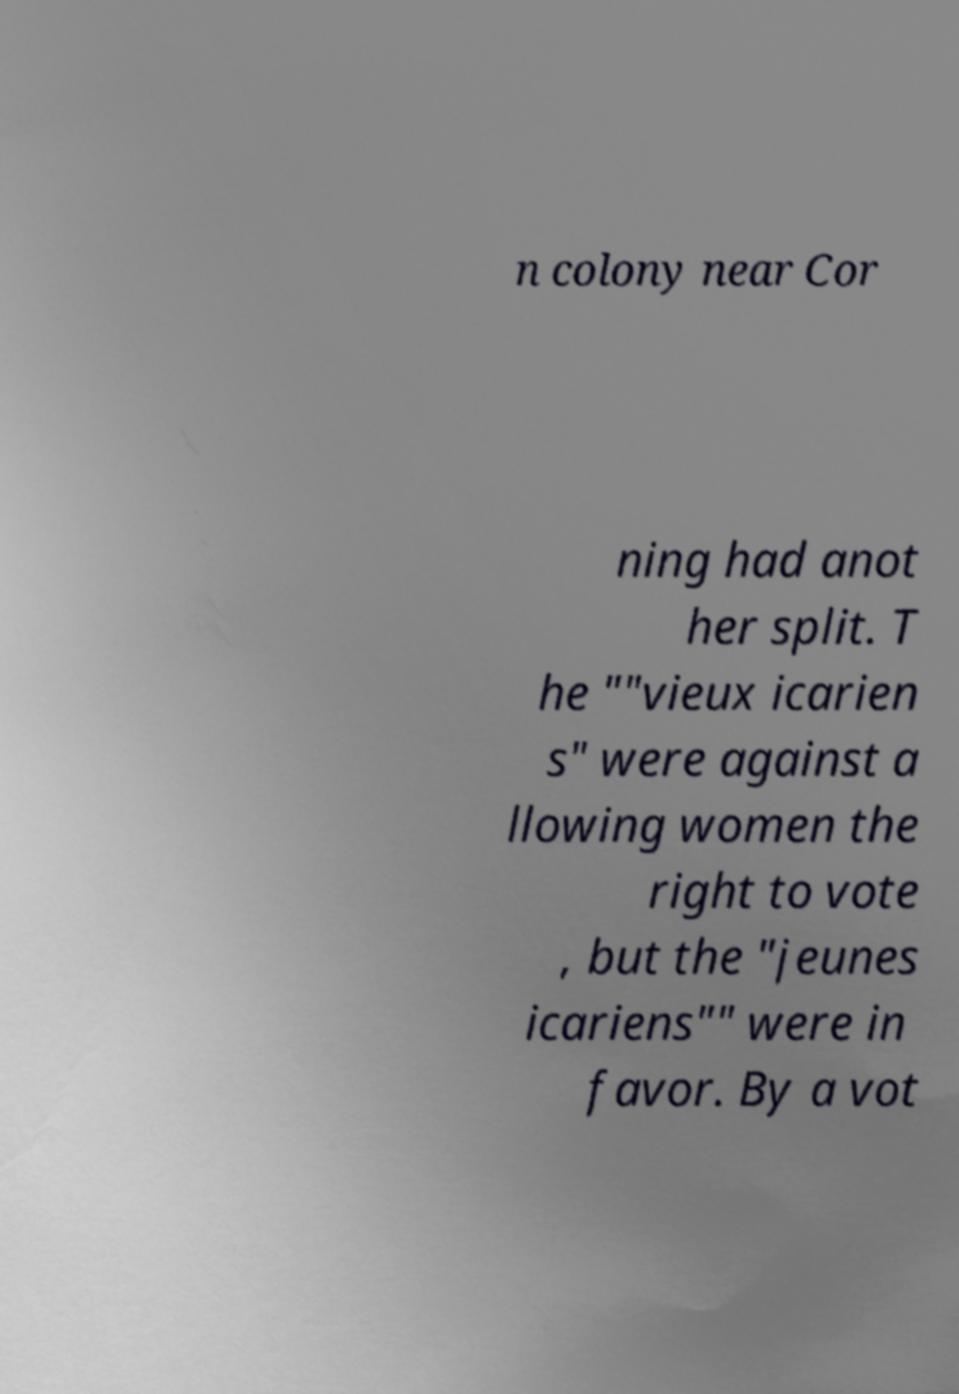I need the written content from this picture converted into text. Can you do that? n colony near Cor ning had anot her split. T he ""vieux icarien s" were against a llowing women the right to vote , but the "jeunes icariens"" were in favor. By a vot 